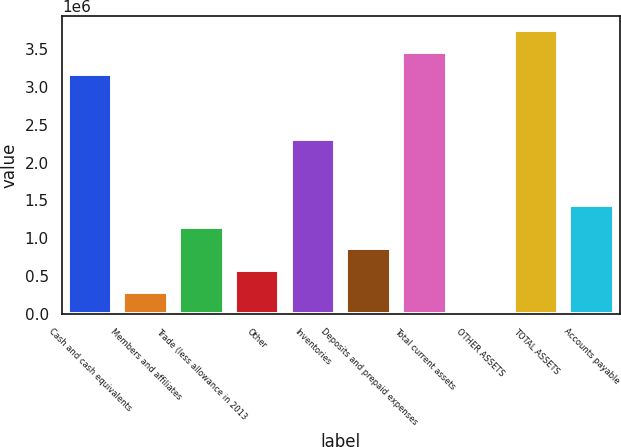Convert chart to OTSL. <chart><loc_0><loc_0><loc_500><loc_500><bar_chart><fcel>Cash and cash equivalents<fcel>Members and affiliates<fcel>Trade (less allowance in 2013<fcel>Other<fcel>Inventories<fcel>Deposits and prepaid expenses<fcel>Total current assets<fcel>OTHER ASSETS<fcel>TOTAL ASSETS<fcel>Accounts payable<nl><fcel>3.17373e+06<fcel>288629<fcel>1.15416e+06<fcel>577139<fcel>2.3082e+06<fcel>865649<fcel>3.46224e+06<fcel>119<fcel>3.75075e+06<fcel>1.44267e+06<nl></chart> 